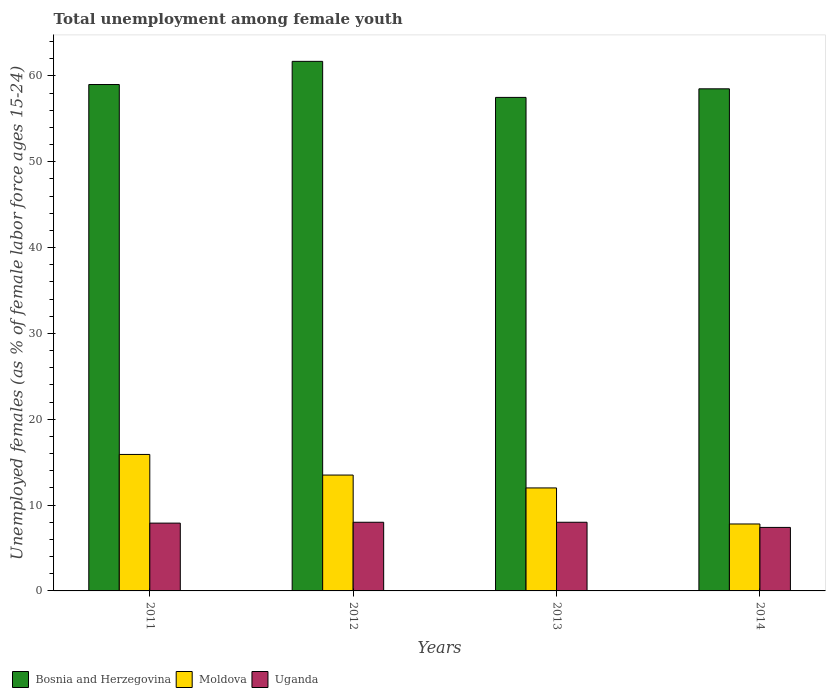How many different coloured bars are there?
Provide a short and direct response. 3. Are the number of bars on each tick of the X-axis equal?
Your answer should be compact. Yes. How many bars are there on the 4th tick from the right?
Give a very brief answer. 3. What is the label of the 1st group of bars from the left?
Keep it short and to the point. 2011. Across all years, what is the maximum percentage of unemployed females in in Bosnia and Herzegovina?
Keep it short and to the point. 61.7. Across all years, what is the minimum percentage of unemployed females in in Uganda?
Your response must be concise. 7.4. In which year was the percentage of unemployed females in in Uganda maximum?
Your response must be concise. 2012. What is the total percentage of unemployed females in in Bosnia and Herzegovina in the graph?
Offer a very short reply. 236.7. What is the difference between the percentage of unemployed females in in Moldova in 2012 and that in 2014?
Keep it short and to the point. 5.7. What is the difference between the percentage of unemployed females in in Uganda in 2012 and the percentage of unemployed females in in Bosnia and Herzegovina in 2013?
Ensure brevity in your answer.  -49.5. What is the average percentage of unemployed females in in Moldova per year?
Your answer should be very brief. 12.3. In the year 2014, what is the difference between the percentage of unemployed females in in Moldova and percentage of unemployed females in in Uganda?
Provide a short and direct response. 0.4. What is the ratio of the percentage of unemployed females in in Uganda in 2011 to that in 2013?
Provide a short and direct response. 0.99. Is the percentage of unemployed females in in Bosnia and Herzegovina in 2011 less than that in 2012?
Ensure brevity in your answer.  Yes. Is the difference between the percentage of unemployed females in in Moldova in 2011 and 2012 greater than the difference between the percentage of unemployed females in in Uganda in 2011 and 2012?
Your answer should be compact. Yes. What is the difference between the highest and the second highest percentage of unemployed females in in Uganda?
Your response must be concise. 0. What is the difference between the highest and the lowest percentage of unemployed females in in Bosnia and Herzegovina?
Provide a succinct answer. 4.2. In how many years, is the percentage of unemployed females in in Moldova greater than the average percentage of unemployed females in in Moldova taken over all years?
Make the answer very short. 2. Is the sum of the percentage of unemployed females in in Uganda in 2012 and 2014 greater than the maximum percentage of unemployed females in in Moldova across all years?
Give a very brief answer. No. What does the 2nd bar from the left in 2014 represents?
Make the answer very short. Moldova. What does the 2nd bar from the right in 2013 represents?
Give a very brief answer. Moldova. How many bars are there?
Make the answer very short. 12. Are all the bars in the graph horizontal?
Give a very brief answer. No. Are the values on the major ticks of Y-axis written in scientific E-notation?
Provide a succinct answer. No. Does the graph contain grids?
Ensure brevity in your answer.  No. Where does the legend appear in the graph?
Make the answer very short. Bottom left. How many legend labels are there?
Offer a terse response. 3. What is the title of the graph?
Make the answer very short. Total unemployment among female youth. Does "Nicaragua" appear as one of the legend labels in the graph?
Your response must be concise. No. What is the label or title of the X-axis?
Your answer should be compact. Years. What is the label or title of the Y-axis?
Keep it short and to the point. Unemployed females (as % of female labor force ages 15-24). What is the Unemployed females (as % of female labor force ages 15-24) in Moldova in 2011?
Provide a succinct answer. 15.9. What is the Unemployed females (as % of female labor force ages 15-24) of Uganda in 2011?
Offer a very short reply. 7.9. What is the Unemployed females (as % of female labor force ages 15-24) in Bosnia and Herzegovina in 2012?
Provide a short and direct response. 61.7. What is the Unemployed females (as % of female labor force ages 15-24) of Bosnia and Herzegovina in 2013?
Provide a short and direct response. 57.5. What is the Unemployed females (as % of female labor force ages 15-24) in Moldova in 2013?
Offer a terse response. 12. What is the Unemployed females (as % of female labor force ages 15-24) of Bosnia and Herzegovina in 2014?
Your answer should be very brief. 58.5. What is the Unemployed females (as % of female labor force ages 15-24) in Moldova in 2014?
Offer a very short reply. 7.8. What is the Unemployed females (as % of female labor force ages 15-24) in Uganda in 2014?
Provide a succinct answer. 7.4. Across all years, what is the maximum Unemployed females (as % of female labor force ages 15-24) of Bosnia and Herzegovina?
Provide a short and direct response. 61.7. Across all years, what is the maximum Unemployed females (as % of female labor force ages 15-24) in Moldova?
Offer a very short reply. 15.9. Across all years, what is the maximum Unemployed females (as % of female labor force ages 15-24) of Uganda?
Your response must be concise. 8. Across all years, what is the minimum Unemployed females (as % of female labor force ages 15-24) in Bosnia and Herzegovina?
Ensure brevity in your answer.  57.5. Across all years, what is the minimum Unemployed females (as % of female labor force ages 15-24) of Moldova?
Your answer should be compact. 7.8. Across all years, what is the minimum Unemployed females (as % of female labor force ages 15-24) in Uganda?
Ensure brevity in your answer.  7.4. What is the total Unemployed females (as % of female labor force ages 15-24) of Bosnia and Herzegovina in the graph?
Make the answer very short. 236.7. What is the total Unemployed females (as % of female labor force ages 15-24) of Moldova in the graph?
Your response must be concise. 49.2. What is the total Unemployed females (as % of female labor force ages 15-24) of Uganda in the graph?
Offer a terse response. 31.3. What is the difference between the Unemployed females (as % of female labor force ages 15-24) in Bosnia and Herzegovina in 2011 and that in 2012?
Give a very brief answer. -2.7. What is the difference between the Unemployed females (as % of female labor force ages 15-24) in Moldova in 2011 and that in 2012?
Ensure brevity in your answer.  2.4. What is the difference between the Unemployed females (as % of female labor force ages 15-24) of Uganda in 2011 and that in 2012?
Ensure brevity in your answer.  -0.1. What is the difference between the Unemployed females (as % of female labor force ages 15-24) in Bosnia and Herzegovina in 2011 and that in 2013?
Keep it short and to the point. 1.5. What is the difference between the Unemployed females (as % of female labor force ages 15-24) of Moldova in 2011 and that in 2013?
Make the answer very short. 3.9. What is the difference between the Unemployed females (as % of female labor force ages 15-24) of Bosnia and Herzegovina in 2011 and that in 2014?
Offer a very short reply. 0.5. What is the difference between the Unemployed females (as % of female labor force ages 15-24) of Moldova in 2011 and that in 2014?
Offer a very short reply. 8.1. What is the difference between the Unemployed females (as % of female labor force ages 15-24) in Uganda in 2011 and that in 2014?
Ensure brevity in your answer.  0.5. What is the difference between the Unemployed females (as % of female labor force ages 15-24) of Moldova in 2012 and that in 2013?
Provide a succinct answer. 1.5. What is the difference between the Unemployed females (as % of female labor force ages 15-24) in Bosnia and Herzegovina in 2012 and that in 2014?
Provide a short and direct response. 3.2. What is the difference between the Unemployed females (as % of female labor force ages 15-24) in Uganda in 2012 and that in 2014?
Give a very brief answer. 0.6. What is the difference between the Unemployed females (as % of female labor force ages 15-24) in Bosnia and Herzegovina in 2013 and that in 2014?
Your answer should be compact. -1. What is the difference between the Unemployed females (as % of female labor force ages 15-24) of Uganda in 2013 and that in 2014?
Make the answer very short. 0.6. What is the difference between the Unemployed females (as % of female labor force ages 15-24) of Bosnia and Herzegovina in 2011 and the Unemployed females (as % of female labor force ages 15-24) of Moldova in 2012?
Your answer should be very brief. 45.5. What is the difference between the Unemployed females (as % of female labor force ages 15-24) in Bosnia and Herzegovina in 2011 and the Unemployed females (as % of female labor force ages 15-24) in Uganda in 2012?
Ensure brevity in your answer.  51. What is the difference between the Unemployed females (as % of female labor force ages 15-24) of Bosnia and Herzegovina in 2011 and the Unemployed females (as % of female labor force ages 15-24) of Uganda in 2013?
Offer a terse response. 51. What is the difference between the Unemployed females (as % of female labor force ages 15-24) in Bosnia and Herzegovina in 2011 and the Unemployed females (as % of female labor force ages 15-24) in Moldova in 2014?
Provide a succinct answer. 51.2. What is the difference between the Unemployed females (as % of female labor force ages 15-24) of Bosnia and Herzegovina in 2011 and the Unemployed females (as % of female labor force ages 15-24) of Uganda in 2014?
Your answer should be very brief. 51.6. What is the difference between the Unemployed females (as % of female labor force ages 15-24) in Moldova in 2011 and the Unemployed females (as % of female labor force ages 15-24) in Uganda in 2014?
Offer a very short reply. 8.5. What is the difference between the Unemployed females (as % of female labor force ages 15-24) of Bosnia and Herzegovina in 2012 and the Unemployed females (as % of female labor force ages 15-24) of Moldova in 2013?
Ensure brevity in your answer.  49.7. What is the difference between the Unemployed females (as % of female labor force ages 15-24) in Bosnia and Herzegovina in 2012 and the Unemployed females (as % of female labor force ages 15-24) in Uganda in 2013?
Offer a very short reply. 53.7. What is the difference between the Unemployed females (as % of female labor force ages 15-24) of Bosnia and Herzegovina in 2012 and the Unemployed females (as % of female labor force ages 15-24) of Moldova in 2014?
Ensure brevity in your answer.  53.9. What is the difference between the Unemployed females (as % of female labor force ages 15-24) of Bosnia and Herzegovina in 2012 and the Unemployed females (as % of female labor force ages 15-24) of Uganda in 2014?
Keep it short and to the point. 54.3. What is the difference between the Unemployed females (as % of female labor force ages 15-24) in Bosnia and Herzegovina in 2013 and the Unemployed females (as % of female labor force ages 15-24) in Moldova in 2014?
Give a very brief answer. 49.7. What is the difference between the Unemployed females (as % of female labor force ages 15-24) in Bosnia and Herzegovina in 2013 and the Unemployed females (as % of female labor force ages 15-24) in Uganda in 2014?
Offer a terse response. 50.1. What is the average Unemployed females (as % of female labor force ages 15-24) in Bosnia and Herzegovina per year?
Keep it short and to the point. 59.17. What is the average Unemployed females (as % of female labor force ages 15-24) in Uganda per year?
Offer a very short reply. 7.83. In the year 2011, what is the difference between the Unemployed females (as % of female labor force ages 15-24) in Bosnia and Herzegovina and Unemployed females (as % of female labor force ages 15-24) in Moldova?
Your answer should be compact. 43.1. In the year 2011, what is the difference between the Unemployed females (as % of female labor force ages 15-24) of Bosnia and Herzegovina and Unemployed females (as % of female labor force ages 15-24) of Uganda?
Offer a very short reply. 51.1. In the year 2012, what is the difference between the Unemployed females (as % of female labor force ages 15-24) in Bosnia and Herzegovina and Unemployed females (as % of female labor force ages 15-24) in Moldova?
Keep it short and to the point. 48.2. In the year 2012, what is the difference between the Unemployed females (as % of female labor force ages 15-24) in Bosnia and Herzegovina and Unemployed females (as % of female labor force ages 15-24) in Uganda?
Offer a very short reply. 53.7. In the year 2012, what is the difference between the Unemployed females (as % of female labor force ages 15-24) of Moldova and Unemployed females (as % of female labor force ages 15-24) of Uganda?
Provide a short and direct response. 5.5. In the year 2013, what is the difference between the Unemployed females (as % of female labor force ages 15-24) in Bosnia and Herzegovina and Unemployed females (as % of female labor force ages 15-24) in Moldova?
Your answer should be compact. 45.5. In the year 2013, what is the difference between the Unemployed females (as % of female labor force ages 15-24) of Bosnia and Herzegovina and Unemployed females (as % of female labor force ages 15-24) of Uganda?
Give a very brief answer. 49.5. In the year 2013, what is the difference between the Unemployed females (as % of female labor force ages 15-24) of Moldova and Unemployed females (as % of female labor force ages 15-24) of Uganda?
Your response must be concise. 4. In the year 2014, what is the difference between the Unemployed females (as % of female labor force ages 15-24) of Bosnia and Herzegovina and Unemployed females (as % of female labor force ages 15-24) of Moldova?
Offer a terse response. 50.7. In the year 2014, what is the difference between the Unemployed females (as % of female labor force ages 15-24) of Bosnia and Herzegovina and Unemployed females (as % of female labor force ages 15-24) of Uganda?
Ensure brevity in your answer.  51.1. In the year 2014, what is the difference between the Unemployed females (as % of female labor force ages 15-24) in Moldova and Unemployed females (as % of female labor force ages 15-24) in Uganda?
Offer a very short reply. 0.4. What is the ratio of the Unemployed females (as % of female labor force ages 15-24) of Bosnia and Herzegovina in 2011 to that in 2012?
Offer a terse response. 0.96. What is the ratio of the Unemployed females (as % of female labor force ages 15-24) of Moldova in 2011 to that in 2012?
Your response must be concise. 1.18. What is the ratio of the Unemployed females (as % of female labor force ages 15-24) of Uganda in 2011 to that in 2012?
Offer a very short reply. 0.99. What is the ratio of the Unemployed females (as % of female labor force ages 15-24) of Bosnia and Herzegovina in 2011 to that in 2013?
Offer a very short reply. 1.03. What is the ratio of the Unemployed females (as % of female labor force ages 15-24) of Moldova in 2011 to that in 2013?
Provide a short and direct response. 1.32. What is the ratio of the Unemployed females (as % of female labor force ages 15-24) of Uganda in 2011 to that in 2013?
Offer a terse response. 0.99. What is the ratio of the Unemployed females (as % of female labor force ages 15-24) of Bosnia and Herzegovina in 2011 to that in 2014?
Make the answer very short. 1.01. What is the ratio of the Unemployed females (as % of female labor force ages 15-24) in Moldova in 2011 to that in 2014?
Provide a succinct answer. 2.04. What is the ratio of the Unemployed females (as % of female labor force ages 15-24) in Uganda in 2011 to that in 2014?
Ensure brevity in your answer.  1.07. What is the ratio of the Unemployed females (as % of female labor force ages 15-24) of Bosnia and Herzegovina in 2012 to that in 2013?
Make the answer very short. 1.07. What is the ratio of the Unemployed females (as % of female labor force ages 15-24) of Uganda in 2012 to that in 2013?
Give a very brief answer. 1. What is the ratio of the Unemployed females (as % of female labor force ages 15-24) in Bosnia and Herzegovina in 2012 to that in 2014?
Your answer should be very brief. 1.05. What is the ratio of the Unemployed females (as % of female labor force ages 15-24) in Moldova in 2012 to that in 2014?
Your response must be concise. 1.73. What is the ratio of the Unemployed females (as % of female labor force ages 15-24) in Uganda in 2012 to that in 2014?
Provide a succinct answer. 1.08. What is the ratio of the Unemployed females (as % of female labor force ages 15-24) in Bosnia and Herzegovina in 2013 to that in 2014?
Offer a terse response. 0.98. What is the ratio of the Unemployed females (as % of female labor force ages 15-24) of Moldova in 2013 to that in 2014?
Your answer should be compact. 1.54. What is the ratio of the Unemployed females (as % of female labor force ages 15-24) of Uganda in 2013 to that in 2014?
Offer a very short reply. 1.08. What is the difference between the highest and the second highest Unemployed females (as % of female labor force ages 15-24) of Bosnia and Herzegovina?
Offer a terse response. 2.7. What is the difference between the highest and the second highest Unemployed females (as % of female labor force ages 15-24) of Moldova?
Ensure brevity in your answer.  2.4. What is the difference between the highest and the second highest Unemployed females (as % of female labor force ages 15-24) of Uganda?
Keep it short and to the point. 0. What is the difference between the highest and the lowest Unemployed females (as % of female labor force ages 15-24) of Bosnia and Herzegovina?
Make the answer very short. 4.2. What is the difference between the highest and the lowest Unemployed females (as % of female labor force ages 15-24) in Moldova?
Provide a short and direct response. 8.1. 